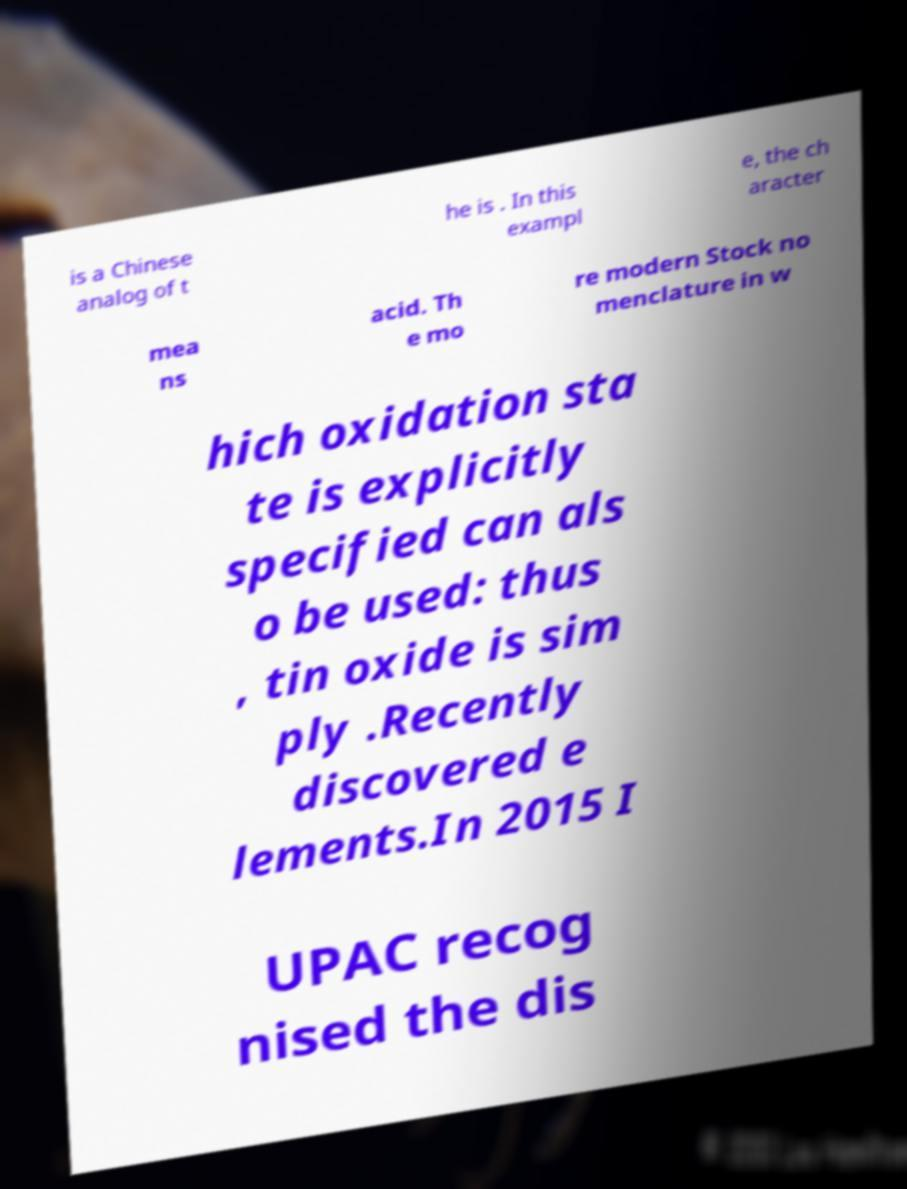Could you extract and type out the text from this image? is a Chinese analog of t he is . In this exampl e, the ch aracter mea ns acid. Th e mo re modern Stock no menclature in w hich oxidation sta te is explicitly specified can als o be used: thus , tin oxide is sim ply .Recently discovered e lements.In 2015 I UPAC recog nised the dis 